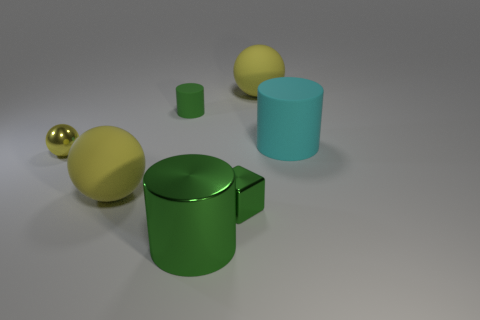Is there a green cube on the right side of the big cylinder behind the big yellow sphere that is in front of the cyan matte cylinder?
Offer a very short reply. No. Are there any other things that have the same shape as the tiny yellow metal object?
Your answer should be very brief. Yes. Are any small yellow metallic balls visible?
Offer a terse response. Yes. Do the green thing behind the tiny yellow shiny sphere and the big sphere in front of the small matte thing have the same material?
Make the answer very short. Yes. There is a cylinder that is behind the matte cylinder that is to the right of the ball that is behind the small green cylinder; what size is it?
Offer a terse response. Small. What number of yellow things have the same material as the big cyan cylinder?
Provide a succinct answer. 2. Is the number of small brown shiny blocks less than the number of metallic cubes?
Your answer should be very brief. Yes. What size is the green metal object that is the same shape as the big cyan thing?
Your response must be concise. Large. Does the green cylinder that is behind the big cyan rubber cylinder have the same material as the small block?
Your response must be concise. No. Do the green matte object and the yellow metal thing have the same shape?
Provide a short and direct response. No. 